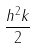<formula> <loc_0><loc_0><loc_500><loc_500>\frac { h ^ { 2 } k } { 2 }</formula> 